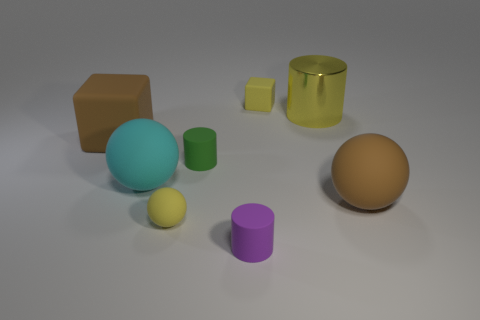How many cubes are left of the tiny purple matte object and to the right of the small yellow matte ball?
Your answer should be compact. 0. Is there any other thing that has the same size as the yellow metal cylinder?
Offer a very short reply. Yes. Are there more shiny cylinders that are behind the yellow block than big objects that are on the right side of the yellow cylinder?
Your answer should be compact. No. What is the brown object in front of the tiny green rubber cylinder made of?
Keep it short and to the point. Rubber. There is a big cyan thing; does it have the same shape as the big rubber object that is behind the small green matte cylinder?
Offer a terse response. No. There is a brown rubber thing that is in front of the brown thing behind the brown matte sphere; how many tiny green things are to the right of it?
Provide a short and direct response. 0. There is another matte object that is the same shape as the tiny green rubber thing; what is its color?
Keep it short and to the point. Purple. Are there any other things that are the same shape as the cyan thing?
Give a very brief answer. Yes. How many balls are gray things or cyan matte objects?
Keep it short and to the point. 1. What is the shape of the large cyan thing?
Keep it short and to the point. Sphere. 